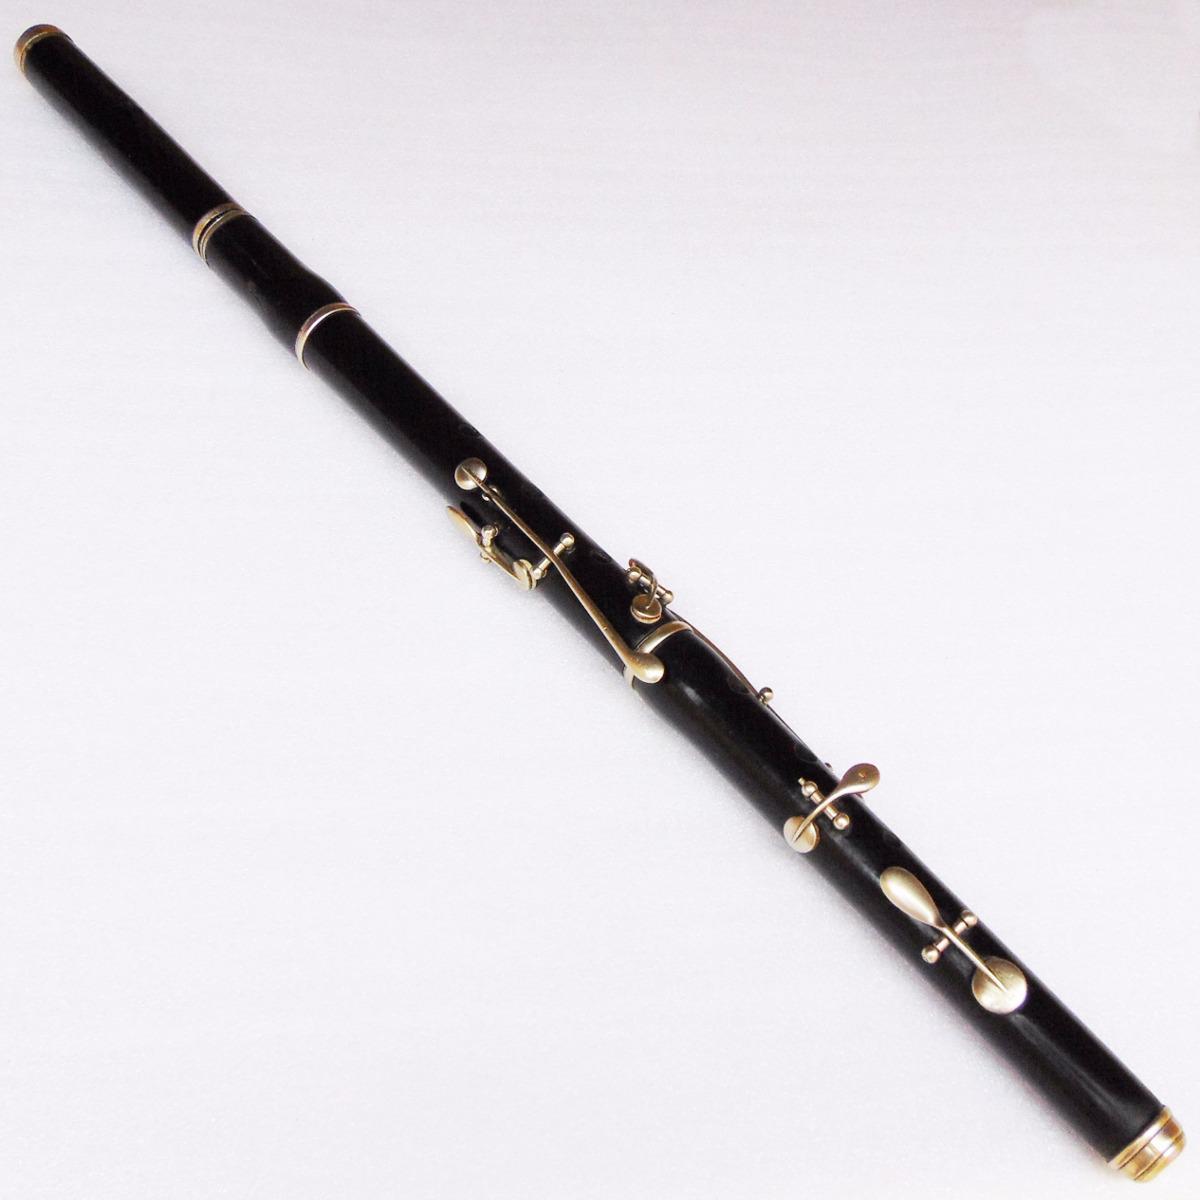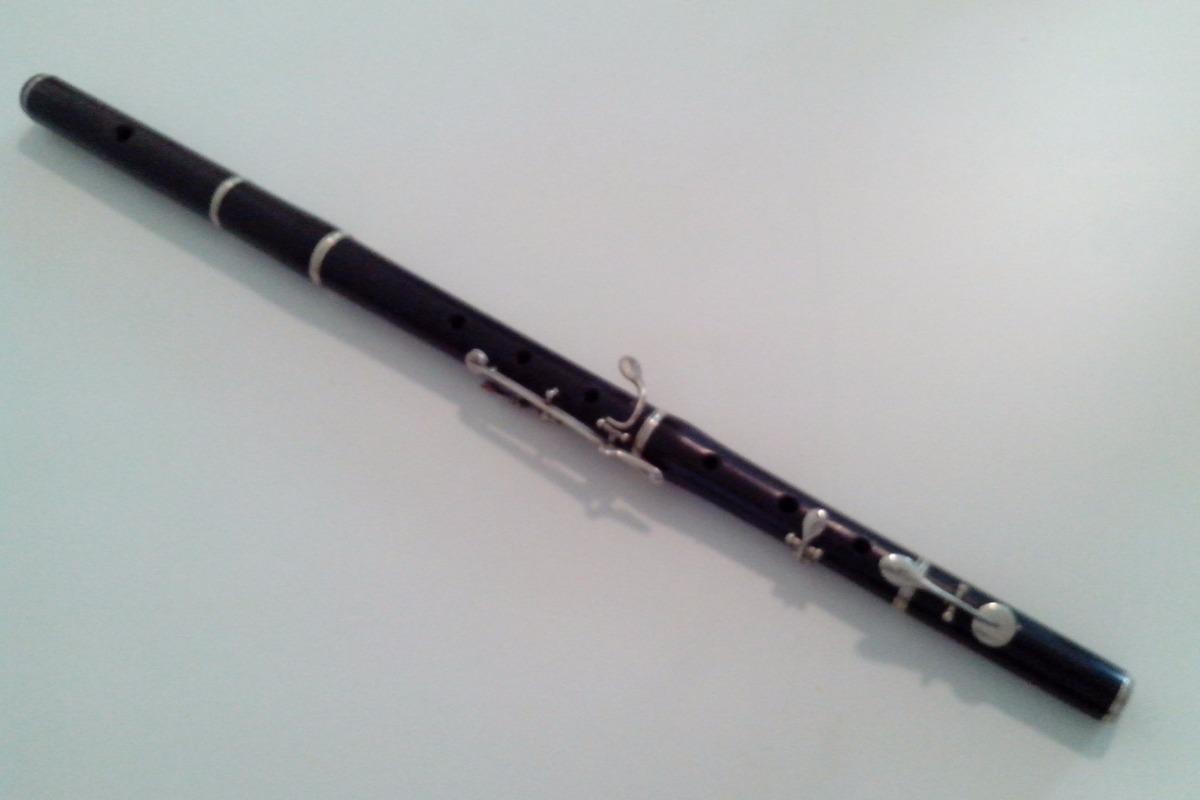The first image is the image on the left, the second image is the image on the right. Examine the images to the left and right. Is the description "One image contains at least three flute pieces displayed in a diagonal, non-touching row, and the other image features one diagonal tube shape with a single hole on its surface." accurate? Answer yes or no. No. The first image is the image on the left, the second image is the image on the right. Analyze the images presented: Is the assertion "In one of the images, there are 3 sections of flute laying parallel to each other." valid? Answer yes or no. No. 